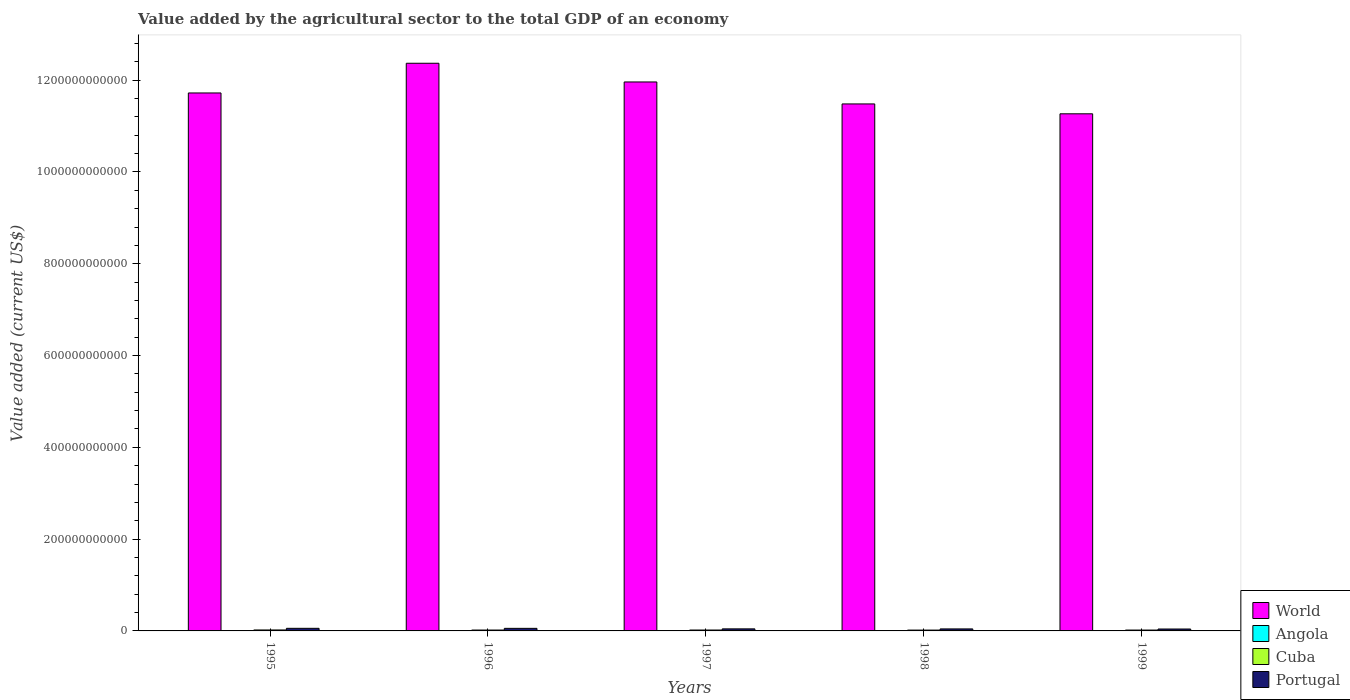How many different coloured bars are there?
Make the answer very short. 4. Are the number of bars per tick equal to the number of legend labels?
Ensure brevity in your answer.  Yes. In how many cases, is the number of bars for a given year not equal to the number of legend labels?
Offer a very short reply. 0. What is the value added by the agricultural sector to the total GDP in Angola in 1999?
Offer a terse response. 3.87e+08. Across all years, what is the maximum value added by the agricultural sector to the total GDP in Portugal?
Give a very brief answer. 5.66e+09. Across all years, what is the minimum value added by the agricultural sector to the total GDP in World?
Ensure brevity in your answer.  1.13e+12. In which year was the value added by the agricultural sector to the total GDP in Cuba minimum?
Make the answer very short. 1998. What is the total value added by the agricultural sector to the total GDP in Portugal in the graph?
Make the answer very short. 2.43e+1. What is the difference between the value added by the agricultural sector to the total GDP in World in 1998 and that in 1999?
Provide a succinct answer. 2.15e+1. What is the difference between the value added by the agricultural sector to the total GDP in Portugal in 1997 and the value added by the agricultural sector to the total GDP in Angola in 1995?
Provide a succinct answer. 4.10e+09. What is the average value added by the agricultural sector to the total GDP in World per year?
Make the answer very short. 1.18e+12. In the year 1998, what is the difference between the value added by the agricultural sector to the total GDP in Portugal and value added by the agricultural sector to the total GDP in Angola?
Your answer should be very brief. 3.54e+09. In how many years, is the value added by the agricultural sector to the total GDP in Portugal greater than 520000000000 US$?
Your response must be concise. 0. What is the ratio of the value added by the agricultural sector to the total GDP in World in 1996 to that in 1999?
Your answer should be very brief. 1.1. What is the difference between the highest and the second highest value added by the agricultural sector to the total GDP in Cuba?
Make the answer very short. 1.22e+08. What is the difference between the highest and the lowest value added by the agricultural sector to the total GDP in Angola?
Provide a succinct answer. 4.70e+08. In how many years, is the value added by the agricultural sector to the total GDP in World greater than the average value added by the agricultural sector to the total GDP in World taken over all years?
Make the answer very short. 2. Is it the case that in every year, the sum of the value added by the agricultural sector to the total GDP in World and value added by the agricultural sector to the total GDP in Cuba is greater than the sum of value added by the agricultural sector to the total GDP in Portugal and value added by the agricultural sector to the total GDP in Angola?
Provide a succinct answer. Yes. How many bars are there?
Offer a very short reply. 20. How many years are there in the graph?
Provide a succinct answer. 5. What is the difference between two consecutive major ticks on the Y-axis?
Give a very brief answer. 2.00e+11. Does the graph contain any zero values?
Make the answer very short. No. Does the graph contain grids?
Ensure brevity in your answer.  No. How are the legend labels stacked?
Make the answer very short. Vertical. What is the title of the graph?
Offer a terse response. Value added by the agricultural sector to the total GDP of an economy. Does "Micronesia" appear as one of the legend labels in the graph?
Provide a succinct answer. No. What is the label or title of the Y-axis?
Ensure brevity in your answer.  Value added (current US$). What is the Value added (current US$) in World in 1995?
Your answer should be very brief. 1.17e+12. What is the Value added (current US$) of Angola in 1995?
Make the answer very short. 3.70e+08. What is the Value added (current US$) of Cuba in 1995?
Your answer should be compact. 2.09e+09. What is the Value added (current US$) in Portugal in 1995?
Provide a short and direct response. 5.66e+09. What is the Value added (current US$) in World in 1996?
Your answer should be very brief. 1.24e+12. What is the Value added (current US$) of Angola in 1996?
Keep it short and to the point. 5.29e+08. What is the Value added (current US$) of Cuba in 1996?
Keep it short and to the point. 1.93e+09. What is the Value added (current US$) in Portugal in 1996?
Provide a short and direct response. 5.60e+09. What is the Value added (current US$) in World in 1997?
Keep it short and to the point. 1.20e+12. What is the Value added (current US$) in Angola in 1997?
Your answer should be very brief. 6.89e+08. What is the Value added (current US$) in Cuba in 1997?
Provide a short and direct response. 1.97e+09. What is the Value added (current US$) of Portugal in 1997?
Offer a very short reply. 4.47e+09. What is the Value added (current US$) in World in 1998?
Provide a short and direct response. 1.15e+12. What is the Value added (current US$) of Angola in 1998?
Keep it short and to the point. 8.40e+08. What is the Value added (current US$) in Cuba in 1998?
Offer a very short reply. 1.82e+09. What is the Value added (current US$) of Portugal in 1998?
Your response must be concise. 4.38e+09. What is the Value added (current US$) in World in 1999?
Your response must be concise. 1.13e+12. What is the Value added (current US$) in Angola in 1999?
Give a very brief answer. 3.87e+08. What is the Value added (current US$) of Cuba in 1999?
Ensure brevity in your answer.  1.87e+09. What is the Value added (current US$) in Portugal in 1999?
Your response must be concise. 4.19e+09. Across all years, what is the maximum Value added (current US$) in World?
Your answer should be compact. 1.24e+12. Across all years, what is the maximum Value added (current US$) of Angola?
Make the answer very short. 8.40e+08. Across all years, what is the maximum Value added (current US$) in Cuba?
Offer a terse response. 2.09e+09. Across all years, what is the maximum Value added (current US$) of Portugal?
Your answer should be compact. 5.66e+09. Across all years, what is the minimum Value added (current US$) of World?
Your answer should be very brief. 1.13e+12. Across all years, what is the minimum Value added (current US$) of Angola?
Give a very brief answer. 3.70e+08. Across all years, what is the minimum Value added (current US$) of Cuba?
Your answer should be compact. 1.82e+09. Across all years, what is the minimum Value added (current US$) of Portugal?
Provide a succinct answer. 4.19e+09. What is the total Value added (current US$) in World in the graph?
Your answer should be compact. 5.88e+12. What is the total Value added (current US$) in Angola in the graph?
Your response must be concise. 2.81e+09. What is the total Value added (current US$) of Cuba in the graph?
Provide a succinct answer. 9.69e+09. What is the total Value added (current US$) in Portugal in the graph?
Provide a short and direct response. 2.43e+1. What is the difference between the Value added (current US$) of World in 1995 and that in 1996?
Make the answer very short. -6.47e+1. What is the difference between the Value added (current US$) of Angola in 1995 and that in 1996?
Offer a very short reply. -1.59e+08. What is the difference between the Value added (current US$) in Cuba in 1995 and that in 1996?
Provide a short and direct response. 1.60e+08. What is the difference between the Value added (current US$) of Portugal in 1995 and that in 1996?
Offer a terse response. 6.24e+07. What is the difference between the Value added (current US$) of World in 1995 and that in 1997?
Provide a succinct answer. -2.40e+1. What is the difference between the Value added (current US$) in Angola in 1995 and that in 1997?
Offer a terse response. -3.19e+08. What is the difference between the Value added (current US$) of Cuba in 1995 and that in 1997?
Provide a short and direct response. 1.22e+08. What is the difference between the Value added (current US$) of Portugal in 1995 and that in 1997?
Your answer should be very brief. 1.18e+09. What is the difference between the Value added (current US$) of World in 1995 and that in 1998?
Make the answer very short. 2.39e+1. What is the difference between the Value added (current US$) in Angola in 1995 and that in 1998?
Make the answer very short. -4.70e+08. What is the difference between the Value added (current US$) in Cuba in 1995 and that in 1998?
Your answer should be very brief. 2.79e+08. What is the difference between the Value added (current US$) in Portugal in 1995 and that in 1998?
Keep it short and to the point. 1.28e+09. What is the difference between the Value added (current US$) in World in 1995 and that in 1999?
Provide a short and direct response. 4.54e+1. What is the difference between the Value added (current US$) in Angola in 1995 and that in 1999?
Provide a succinct answer. -1.70e+07. What is the difference between the Value added (current US$) of Cuba in 1995 and that in 1999?
Make the answer very short. 2.20e+08. What is the difference between the Value added (current US$) in Portugal in 1995 and that in 1999?
Keep it short and to the point. 1.47e+09. What is the difference between the Value added (current US$) in World in 1996 and that in 1997?
Keep it short and to the point. 4.07e+1. What is the difference between the Value added (current US$) of Angola in 1996 and that in 1997?
Ensure brevity in your answer.  -1.60e+08. What is the difference between the Value added (current US$) in Cuba in 1996 and that in 1997?
Offer a terse response. -3.78e+07. What is the difference between the Value added (current US$) in Portugal in 1996 and that in 1997?
Provide a succinct answer. 1.12e+09. What is the difference between the Value added (current US$) of World in 1996 and that in 1998?
Offer a terse response. 8.86e+1. What is the difference between the Value added (current US$) in Angola in 1996 and that in 1998?
Make the answer very short. -3.11e+08. What is the difference between the Value added (current US$) in Cuba in 1996 and that in 1998?
Offer a terse response. 1.19e+08. What is the difference between the Value added (current US$) of Portugal in 1996 and that in 1998?
Offer a terse response. 1.21e+09. What is the difference between the Value added (current US$) of World in 1996 and that in 1999?
Offer a very short reply. 1.10e+11. What is the difference between the Value added (current US$) of Angola in 1996 and that in 1999?
Make the answer very short. 1.42e+08. What is the difference between the Value added (current US$) in Cuba in 1996 and that in 1999?
Make the answer very short. 6.04e+07. What is the difference between the Value added (current US$) in Portugal in 1996 and that in 1999?
Your answer should be compact. 1.41e+09. What is the difference between the Value added (current US$) in World in 1997 and that in 1998?
Make the answer very short. 4.79e+1. What is the difference between the Value added (current US$) of Angola in 1997 and that in 1998?
Your response must be concise. -1.51e+08. What is the difference between the Value added (current US$) of Cuba in 1997 and that in 1998?
Your answer should be compact. 1.57e+08. What is the difference between the Value added (current US$) in Portugal in 1997 and that in 1998?
Give a very brief answer. 9.32e+07. What is the difference between the Value added (current US$) in World in 1997 and that in 1999?
Provide a short and direct response. 6.94e+1. What is the difference between the Value added (current US$) in Angola in 1997 and that in 1999?
Provide a succinct answer. 3.02e+08. What is the difference between the Value added (current US$) of Cuba in 1997 and that in 1999?
Keep it short and to the point. 9.82e+07. What is the difference between the Value added (current US$) in Portugal in 1997 and that in 1999?
Your answer should be very brief. 2.89e+08. What is the difference between the Value added (current US$) of World in 1998 and that in 1999?
Your response must be concise. 2.15e+1. What is the difference between the Value added (current US$) of Angola in 1998 and that in 1999?
Give a very brief answer. 4.53e+08. What is the difference between the Value added (current US$) in Cuba in 1998 and that in 1999?
Make the answer very short. -5.87e+07. What is the difference between the Value added (current US$) of Portugal in 1998 and that in 1999?
Provide a succinct answer. 1.96e+08. What is the difference between the Value added (current US$) in World in 1995 and the Value added (current US$) in Angola in 1996?
Offer a terse response. 1.17e+12. What is the difference between the Value added (current US$) of World in 1995 and the Value added (current US$) of Cuba in 1996?
Your answer should be compact. 1.17e+12. What is the difference between the Value added (current US$) in World in 1995 and the Value added (current US$) in Portugal in 1996?
Your response must be concise. 1.17e+12. What is the difference between the Value added (current US$) of Angola in 1995 and the Value added (current US$) of Cuba in 1996?
Offer a very short reply. -1.56e+09. What is the difference between the Value added (current US$) of Angola in 1995 and the Value added (current US$) of Portugal in 1996?
Make the answer very short. -5.23e+09. What is the difference between the Value added (current US$) of Cuba in 1995 and the Value added (current US$) of Portugal in 1996?
Offer a terse response. -3.50e+09. What is the difference between the Value added (current US$) of World in 1995 and the Value added (current US$) of Angola in 1997?
Keep it short and to the point. 1.17e+12. What is the difference between the Value added (current US$) in World in 1995 and the Value added (current US$) in Cuba in 1997?
Your answer should be very brief. 1.17e+12. What is the difference between the Value added (current US$) of World in 1995 and the Value added (current US$) of Portugal in 1997?
Your response must be concise. 1.17e+12. What is the difference between the Value added (current US$) in Angola in 1995 and the Value added (current US$) in Cuba in 1997?
Provide a short and direct response. -1.60e+09. What is the difference between the Value added (current US$) in Angola in 1995 and the Value added (current US$) in Portugal in 1997?
Your response must be concise. -4.10e+09. What is the difference between the Value added (current US$) of Cuba in 1995 and the Value added (current US$) of Portugal in 1997?
Provide a succinct answer. -2.38e+09. What is the difference between the Value added (current US$) in World in 1995 and the Value added (current US$) in Angola in 1998?
Your answer should be very brief. 1.17e+12. What is the difference between the Value added (current US$) of World in 1995 and the Value added (current US$) of Cuba in 1998?
Provide a short and direct response. 1.17e+12. What is the difference between the Value added (current US$) of World in 1995 and the Value added (current US$) of Portugal in 1998?
Offer a terse response. 1.17e+12. What is the difference between the Value added (current US$) in Angola in 1995 and the Value added (current US$) in Cuba in 1998?
Make the answer very short. -1.45e+09. What is the difference between the Value added (current US$) in Angola in 1995 and the Value added (current US$) in Portugal in 1998?
Make the answer very short. -4.01e+09. What is the difference between the Value added (current US$) of Cuba in 1995 and the Value added (current US$) of Portugal in 1998?
Give a very brief answer. -2.29e+09. What is the difference between the Value added (current US$) of World in 1995 and the Value added (current US$) of Angola in 1999?
Your answer should be compact. 1.17e+12. What is the difference between the Value added (current US$) of World in 1995 and the Value added (current US$) of Cuba in 1999?
Your response must be concise. 1.17e+12. What is the difference between the Value added (current US$) in World in 1995 and the Value added (current US$) in Portugal in 1999?
Provide a succinct answer. 1.17e+12. What is the difference between the Value added (current US$) of Angola in 1995 and the Value added (current US$) of Cuba in 1999?
Make the answer very short. -1.50e+09. What is the difference between the Value added (current US$) in Angola in 1995 and the Value added (current US$) in Portugal in 1999?
Keep it short and to the point. -3.82e+09. What is the difference between the Value added (current US$) in Cuba in 1995 and the Value added (current US$) in Portugal in 1999?
Your answer should be compact. -2.09e+09. What is the difference between the Value added (current US$) of World in 1996 and the Value added (current US$) of Angola in 1997?
Provide a succinct answer. 1.24e+12. What is the difference between the Value added (current US$) in World in 1996 and the Value added (current US$) in Cuba in 1997?
Provide a succinct answer. 1.23e+12. What is the difference between the Value added (current US$) of World in 1996 and the Value added (current US$) of Portugal in 1997?
Keep it short and to the point. 1.23e+12. What is the difference between the Value added (current US$) of Angola in 1996 and the Value added (current US$) of Cuba in 1997?
Your response must be concise. -1.44e+09. What is the difference between the Value added (current US$) of Angola in 1996 and the Value added (current US$) of Portugal in 1997?
Offer a terse response. -3.95e+09. What is the difference between the Value added (current US$) in Cuba in 1996 and the Value added (current US$) in Portugal in 1997?
Your answer should be very brief. -2.54e+09. What is the difference between the Value added (current US$) in World in 1996 and the Value added (current US$) in Angola in 1998?
Give a very brief answer. 1.24e+12. What is the difference between the Value added (current US$) of World in 1996 and the Value added (current US$) of Cuba in 1998?
Provide a short and direct response. 1.24e+12. What is the difference between the Value added (current US$) of World in 1996 and the Value added (current US$) of Portugal in 1998?
Make the answer very short. 1.23e+12. What is the difference between the Value added (current US$) in Angola in 1996 and the Value added (current US$) in Cuba in 1998?
Give a very brief answer. -1.29e+09. What is the difference between the Value added (current US$) in Angola in 1996 and the Value added (current US$) in Portugal in 1998?
Provide a succinct answer. -3.85e+09. What is the difference between the Value added (current US$) in Cuba in 1996 and the Value added (current US$) in Portugal in 1998?
Provide a short and direct response. -2.45e+09. What is the difference between the Value added (current US$) in World in 1996 and the Value added (current US$) in Angola in 1999?
Provide a short and direct response. 1.24e+12. What is the difference between the Value added (current US$) in World in 1996 and the Value added (current US$) in Cuba in 1999?
Your answer should be very brief. 1.23e+12. What is the difference between the Value added (current US$) of World in 1996 and the Value added (current US$) of Portugal in 1999?
Your answer should be compact. 1.23e+12. What is the difference between the Value added (current US$) in Angola in 1996 and the Value added (current US$) in Cuba in 1999?
Offer a very short reply. -1.35e+09. What is the difference between the Value added (current US$) in Angola in 1996 and the Value added (current US$) in Portugal in 1999?
Offer a terse response. -3.66e+09. What is the difference between the Value added (current US$) of Cuba in 1996 and the Value added (current US$) of Portugal in 1999?
Offer a terse response. -2.25e+09. What is the difference between the Value added (current US$) of World in 1997 and the Value added (current US$) of Angola in 1998?
Make the answer very short. 1.20e+12. What is the difference between the Value added (current US$) in World in 1997 and the Value added (current US$) in Cuba in 1998?
Offer a terse response. 1.19e+12. What is the difference between the Value added (current US$) in World in 1997 and the Value added (current US$) in Portugal in 1998?
Keep it short and to the point. 1.19e+12. What is the difference between the Value added (current US$) of Angola in 1997 and the Value added (current US$) of Cuba in 1998?
Your answer should be very brief. -1.13e+09. What is the difference between the Value added (current US$) of Angola in 1997 and the Value added (current US$) of Portugal in 1998?
Keep it short and to the point. -3.69e+09. What is the difference between the Value added (current US$) of Cuba in 1997 and the Value added (current US$) of Portugal in 1998?
Ensure brevity in your answer.  -2.41e+09. What is the difference between the Value added (current US$) in World in 1997 and the Value added (current US$) in Angola in 1999?
Keep it short and to the point. 1.20e+12. What is the difference between the Value added (current US$) of World in 1997 and the Value added (current US$) of Cuba in 1999?
Keep it short and to the point. 1.19e+12. What is the difference between the Value added (current US$) of World in 1997 and the Value added (current US$) of Portugal in 1999?
Your response must be concise. 1.19e+12. What is the difference between the Value added (current US$) of Angola in 1997 and the Value added (current US$) of Cuba in 1999?
Ensure brevity in your answer.  -1.19e+09. What is the difference between the Value added (current US$) of Angola in 1997 and the Value added (current US$) of Portugal in 1999?
Your response must be concise. -3.50e+09. What is the difference between the Value added (current US$) in Cuba in 1997 and the Value added (current US$) in Portugal in 1999?
Offer a very short reply. -2.21e+09. What is the difference between the Value added (current US$) of World in 1998 and the Value added (current US$) of Angola in 1999?
Your response must be concise. 1.15e+12. What is the difference between the Value added (current US$) of World in 1998 and the Value added (current US$) of Cuba in 1999?
Provide a succinct answer. 1.15e+12. What is the difference between the Value added (current US$) of World in 1998 and the Value added (current US$) of Portugal in 1999?
Keep it short and to the point. 1.14e+12. What is the difference between the Value added (current US$) in Angola in 1998 and the Value added (current US$) in Cuba in 1999?
Keep it short and to the point. -1.03e+09. What is the difference between the Value added (current US$) in Angola in 1998 and the Value added (current US$) in Portugal in 1999?
Make the answer very short. -3.35e+09. What is the difference between the Value added (current US$) of Cuba in 1998 and the Value added (current US$) of Portugal in 1999?
Offer a terse response. -2.37e+09. What is the average Value added (current US$) in World per year?
Offer a very short reply. 1.18e+12. What is the average Value added (current US$) in Angola per year?
Your answer should be very brief. 5.63e+08. What is the average Value added (current US$) of Cuba per year?
Provide a succinct answer. 1.94e+09. What is the average Value added (current US$) in Portugal per year?
Offer a terse response. 4.86e+09. In the year 1995, what is the difference between the Value added (current US$) of World and Value added (current US$) of Angola?
Your answer should be compact. 1.17e+12. In the year 1995, what is the difference between the Value added (current US$) in World and Value added (current US$) in Cuba?
Your answer should be compact. 1.17e+12. In the year 1995, what is the difference between the Value added (current US$) of World and Value added (current US$) of Portugal?
Make the answer very short. 1.17e+12. In the year 1995, what is the difference between the Value added (current US$) of Angola and Value added (current US$) of Cuba?
Give a very brief answer. -1.72e+09. In the year 1995, what is the difference between the Value added (current US$) in Angola and Value added (current US$) in Portugal?
Provide a succinct answer. -5.29e+09. In the year 1995, what is the difference between the Value added (current US$) in Cuba and Value added (current US$) in Portugal?
Ensure brevity in your answer.  -3.56e+09. In the year 1996, what is the difference between the Value added (current US$) of World and Value added (current US$) of Angola?
Offer a terse response. 1.24e+12. In the year 1996, what is the difference between the Value added (current US$) of World and Value added (current US$) of Cuba?
Provide a short and direct response. 1.23e+12. In the year 1996, what is the difference between the Value added (current US$) of World and Value added (current US$) of Portugal?
Offer a terse response. 1.23e+12. In the year 1996, what is the difference between the Value added (current US$) of Angola and Value added (current US$) of Cuba?
Your answer should be compact. -1.41e+09. In the year 1996, what is the difference between the Value added (current US$) in Angola and Value added (current US$) in Portugal?
Your response must be concise. -5.07e+09. In the year 1996, what is the difference between the Value added (current US$) of Cuba and Value added (current US$) of Portugal?
Provide a succinct answer. -3.66e+09. In the year 1997, what is the difference between the Value added (current US$) in World and Value added (current US$) in Angola?
Ensure brevity in your answer.  1.20e+12. In the year 1997, what is the difference between the Value added (current US$) of World and Value added (current US$) of Cuba?
Make the answer very short. 1.19e+12. In the year 1997, what is the difference between the Value added (current US$) in World and Value added (current US$) in Portugal?
Ensure brevity in your answer.  1.19e+12. In the year 1997, what is the difference between the Value added (current US$) in Angola and Value added (current US$) in Cuba?
Your answer should be compact. -1.28e+09. In the year 1997, what is the difference between the Value added (current US$) in Angola and Value added (current US$) in Portugal?
Ensure brevity in your answer.  -3.79e+09. In the year 1997, what is the difference between the Value added (current US$) in Cuba and Value added (current US$) in Portugal?
Make the answer very short. -2.50e+09. In the year 1998, what is the difference between the Value added (current US$) in World and Value added (current US$) in Angola?
Ensure brevity in your answer.  1.15e+12. In the year 1998, what is the difference between the Value added (current US$) in World and Value added (current US$) in Cuba?
Offer a terse response. 1.15e+12. In the year 1998, what is the difference between the Value added (current US$) in World and Value added (current US$) in Portugal?
Your answer should be compact. 1.14e+12. In the year 1998, what is the difference between the Value added (current US$) in Angola and Value added (current US$) in Cuba?
Offer a very short reply. -9.75e+08. In the year 1998, what is the difference between the Value added (current US$) in Angola and Value added (current US$) in Portugal?
Give a very brief answer. -3.54e+09. In the year 1998, what is the difference between the Value added (current US$) of Cuba and Value added (current US$) of Portugal?
Keep it short and to the point. -2.57e+09. In the year 1999, what is the difference between the Value added (current US$) of World and Value added (current US$) of Angola?
Keep it short and to the point. 1.13e+12. In the year 1999, what is the difference between the Value added (current US$) of World and Value added (current US$) of Cuba?
Ensure brevity in your answer.  1.12e+12. In the year 1999, what is the difference between the Value added (current US$) of World and Value added (current US$) of Portugal?
Provide a short and direct response. 1.12e+12. In the year 1999, what is the difference between the Value added (current US$) of Angola and Value added (current US$) of Cuba?
Provide a succinct answer. -1.49e+09. In the year 1999, what is the difference between the Value added (current US$) of Angola and Value added (current US$) of Portugal?
Your answer should be very brief. -3.80e+09. In the year 1999, what is the difference between the Value added (current US$) in Cuba and Value added (current US$) in Portugal?
Your answer should be very brief. -2.31e+09. What is the ratio of the Value added (current US$) of World in 1995 to that in 1996?
Offer a terse response. 0.95. What is the ratio of the Value added (current US$) of Angola in 1995 to that in 1996?
Make the answer very short. 0.7. What is the ratio of the Value added (current US$) of Cuba in 1995 to that in 1996?
Your answer should be very brief. 1.08. What is the ratio of the Value added (current US$) in Portugal in 1995 to that in 1996?
Provide a succinct answer. 1.01. What is the ratio of the Value added (current US$) in World in 1995 to that in 1997?
Keep it short and to the point. 0.98. What is the ratio of the Value added (current US$) in Angola in 1995 to that in 1997?
Give a very brief answer. 0.54. What is the ratio of the Value added (current US$) in Cuba in 1995 to that in 1997?
Provide a succinct answer. 1.06. What is the ratio of the Value added (current US$) of Portugal in 1995 to that in 1997?
Offer a very short reply. 1.26. What is the ratio of the Value added (current US$) in World in 1995 to that in 1998?
Ensure brevity in your answer.  1.02. What is the ratio of the Value added (current US$) in Angola in 1995 to that in 1998?
Ensure brevity in your answer.  0.44. What is the ratio of the Value added (current US$) of Cuba in 1995 to that in 1998?
Your answer should be very brief. 1.15. What is the ratio of the Value added (current US$) in Portugal in 1995 to that in 1998?
Your answer should be very brief. 1.29. What is the ratio of the Value added (current US$) in World in 1995 to that in 1999?
Offer a very short reply. 1.04. What is the ratio of the Value added (current US$) in Angola in 1995 to that in 1999?
Your response must be concise. 0.96. What is the ratio of the Value added (current US$) of Cuba in 1995 to that in 1999?
Your answer should be very brief. 1.12. What is the ratio of the Value added (current US$) in Portugal in 1995 to that in 1999?
Provide a succinct answer. 1.35. What is the ratio of the Value added (current US$) in World in 1996 to that in 1997?
Keep it short and to the point. 1.03. What is the ratio of the Value added (current US$) in Angola in 1996 to that in 1997?
Give a very brief answer. 0.77. What is the ratio of the Value added (current US$) of Cuba in 1996 to that in 1997?
Your answer should be very brief. 0.98. What is the ratio of the Value added (current US$) of Portugal in 1996 to that in 1997?
Provide a succinct answer. 1.25. What is the ratio of the Value added (current US$) of World in 1996 to that in 1998?
Offer a terse response. 1.08. What is the ratio of the Value added (current US$) of Angola in 1996 to that in 1998?
Keep it short and to the point. 0.63. What is the ratio of the Value added (current US$) of Cuba in 1996 to that in 1998?
Offer a terse response. 1.07. What is the ratio of the Value added (current US$) of Portugal in 1996 to that in 1998?
Make the answer very short. 1.28. What is the ratio of the Value added (current US$) of World in 1996 to that in 1999?
Give a very brief answer. 1.1. What is the ratio of the Value added (current US$) of Angola in 1996 to that in 1999?
Give a very brief answer. 1.37. What is the ratio of the Value added (current US$) of Cuba in 1996 to that in 1999?
Offer a very short reply. 1.03. What is the ratio of the Value added (current US$) of Portugal in 1996 to that in 1999?
Provide a short and direct response. 1.34. What is the ratio of the Value added (current US$) of World in 1997 to that in 1998?
Your response must be concise. 1.04. What is the ratio of the Value added (current US$) of Angola in 1997 to that in 1998?
Provide a short and direct response. 0.82. What is the ratio of the Value added (current US$) in Cuba in 1997 to that in 1998?
Keep it short and to the point. 1.09. What is the ratio of the Value added (current US$) of Portugal in 1997 to that in 1998?
Offer a very short reply. 1.02. What is the ratio of the Value added (current US$) of World in 1997 to that in 1999?
Make the answer very short. 1.06. What is the ratio of the Value added (current US$) of Angola in 1997 to that in 1999?
Your answer should be compact. 1.78. What is the ratio of the Value added (current US$) in Cuba in 1997 to that in 1999?
Keep it short and to the point. 1.05. What is the ratio of the Value added (current US$) of Portugal in 1997 to that in 1999?
Your answer should be very brief. 1.07. What is the ratio of the Value added (current US$) in World in 1998 to that in 1999?
Ensure brevity in your answer.  1.02. What is the ratio of the Value added (current US$) in Angola in 1998 to that in 1999?
Your answer should be very brief. 2.17. What is the ratio of the Value added (current US$) in Cuba in 1998 to that in 1999?
Your answer should be compact. 0.97. What is the ratio of the Value added (current US$) of Portugal in 1998 to that in 1999?
Provide a short and direct response. 1.05. What is the difference between the highest and the second highest Value added (current US$) in World?
Provide a short and direct response. 4.07e+1. What is the difference between the highest and the second highest Value added (current US$) in Angola?
Ensure brevity in your answer.  1.51e+08. What is the difference between the highest and the second highest Value added (current US$) in Cuba?
Keep it short and to the point. 1.22e+08. What is the difference between the highest and the second highest Value added (current US$) of Portugal?
Provide a short and direct response. 6.24e+07. What is the difference between the highest and the lowest Value added (current US$) of World?
Keep it short and to the point. 1.10e+11. What is the difference between the highest and the lowest Value added (current US$) in Angola?
Offer a terse response. 4.70e+08. What is the difference between the highest and the lowest Value added (current US$) of Cuba?
Give a very brief answer. 2.79e+08. What is the difference between the highest and the lowest Value added (current US$) in Portugal?
Your response must be concise. 1.47e+09. 